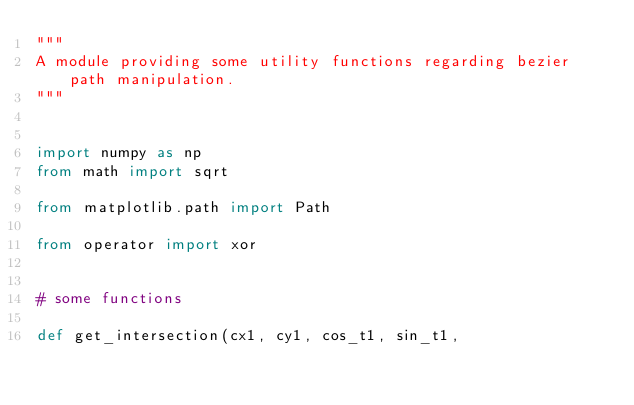Convert code to text. <code><loc_0><loc_0><loc_500><loc_500><_Python_>"""
A module providing some utility functions regarding bezier path manipulation.
"""


import numpy as np
from math import sqrt

from matplotlib.path import Path

from operator import xor


# some functions

def get_intersection(cx1, cy1, cos_t1, sin_t1,</code> 